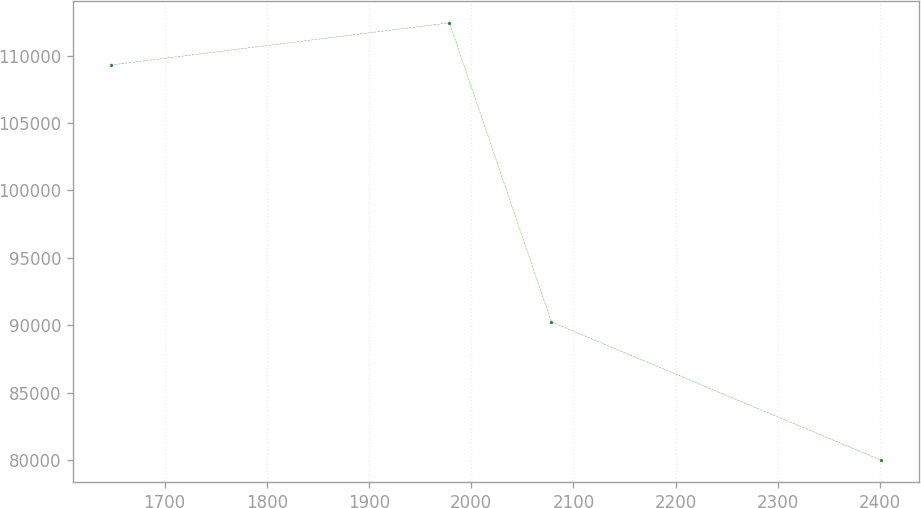<chart> <loc_0><loc_0><loc_500><loc_500><line_chart><ecel><fcel>Unnamed: 1<nl><fcel>1647.93<fcel>109303<nl><fcel>1978.79<fcel>112427<nl><fcel>2078.47<fcel>90252.5<nl><fcel>2400.83<fcel>80007.9<nl></chart> 